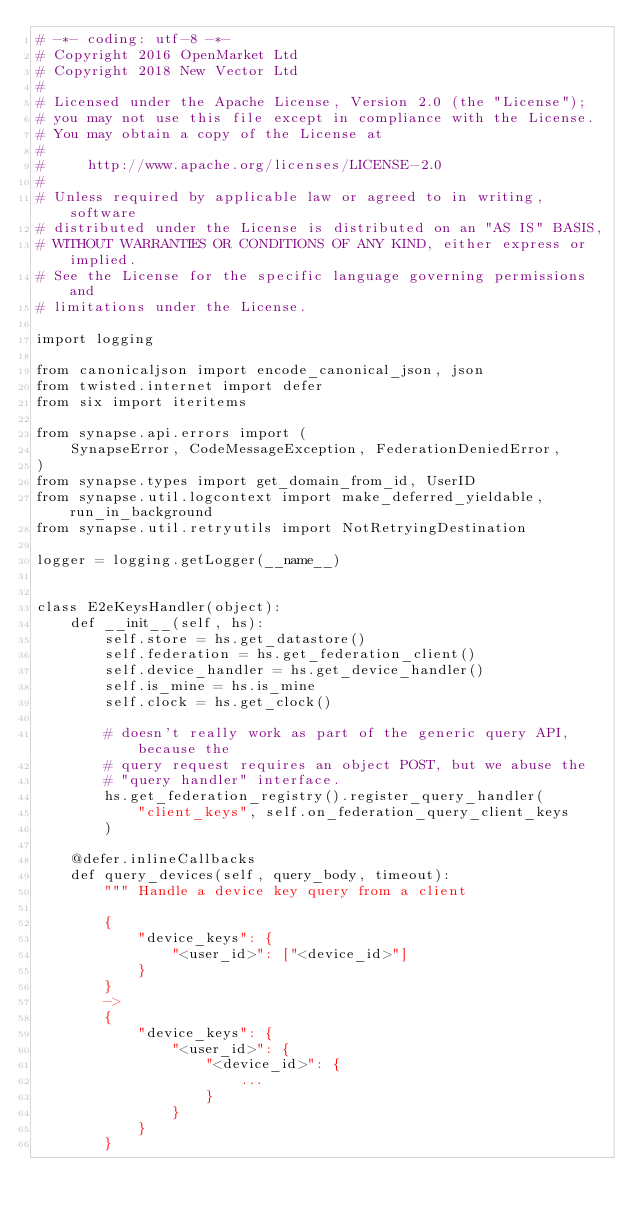Convert code to text. <code><loc_0><loc_0><loc_500><loc_500><_Python_># -*- coding: utf-8 -*-
# Copyright 2016 OpenMarket Ltd
# Copyright 2018 New Vector Ltd
#
# Licensed under the Apache License, Version 2.0 (the "License");
# you may not use this file except in compliance with the License.
# You may obtain a copy of the License at
#
#     http://www.apache.org/licenses/LICENSE-2.0
#
# Unless required by applicable law or agreed to in writing, software
# distributed under the License is distributed on an "AS IS" BASIS,
# WITHOUT WARRANTIES OR CONDITIONS OF ANY KIND, either express or implied.
# See the License for the specific language governing permissions and
# limitations under the License.

import logging

from canonicaljson import encode_canonical_json, json
from twisted.internet import defer
from six import iteritems

from synapse.api.errors import (
    SynapseError, CodeMessageException, FederationDeniedError,
)
from synapse.types import get_domain_from_id, UserID
from synapse.util.logcontext import make_deferred_yieldable, run_in_background
from synapse.util.retryutils import NotRetryingDestination

logger = logging.getLogger(__name__)


class E2eKeysHandler(object):
    def __init__(self, hs):
        self.store = hs.get_datastore()
        self.federation = hs.get_federation_client()
        self.device_handler = hs.get_device_handler()
        self.is_mine = hs.is_mine
        self.clock = hs.get_clock()

        # doesn't really work as part of the generic query API, because the
        # query request requires an object POST, but we abuse the
        # "query handler" interface.
        hs.get_federation_registry().register_query_handler(
            "client_keys", self.on_federation_query_client_keys
        )

    @defer.inlineCallbacks
    def query_devices(self, query_body, timeout):
        """ Handle a device key query from a client

        {
            "device_keys": {
                "<user_id>": ["<device_id>"]
            }
        }
        ->
        {
            "device_keys": {
                "<user_id>": {
                    "<device_id>": {
                        ...
                    }
                }
            }
        }</code> 